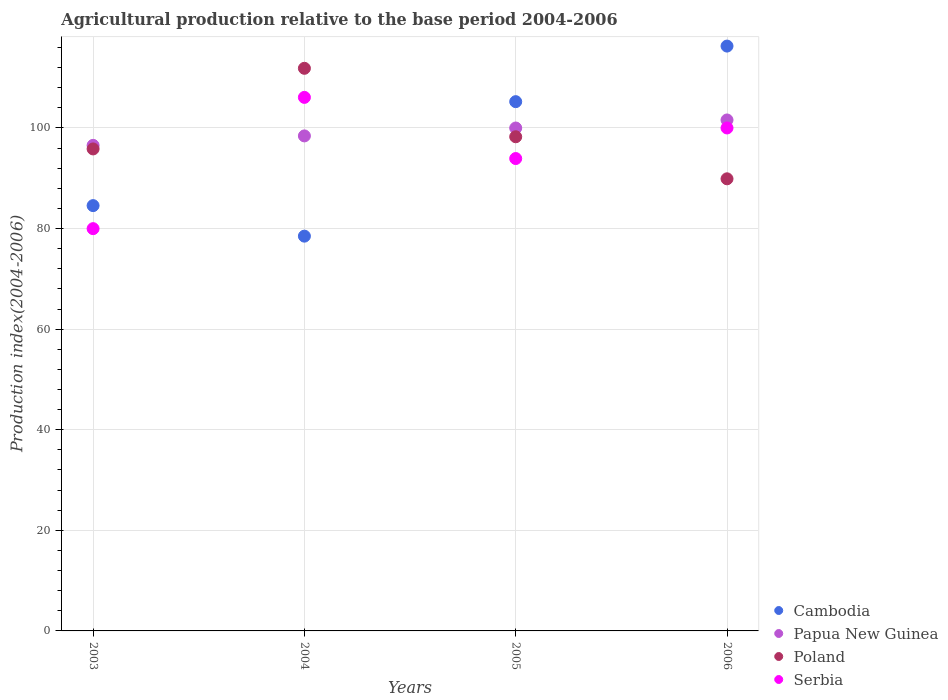Is the number of dotlines equal to the number of legend labels?
Give a very brief answer. Yes. What is the agricultural production index in Serbia in 2005?
Offer a terse response. 93.92. Across all years, what is the maximum agricultural production index in Poland?
Offer a terse response. 111.86. Across all years, what is the minimum agricultural production index in Poland?
Provide a short and direct response. 89.89. In which year was the agricultural production index in Serbia maximum?
Offer a very short reply. 2004. In which year was the agricultural production index in Papua New Guinea minimum?
Offer a terse response. 2003. What is the total agricultural production index in Cambodia in the graph?
Provide a succinct answer. 384.56. What is the difference between the agricultural production index in Cambodia in 2003 and that in 2004?
Provide a succinct answer. 6.07. What is the difference between the agricultural production index in Cambodia in 2006 and the agricultural production index in Poland in 2003?
Your answer should be compact. 20.45. What is the average agricultural production index in Cambodia per year?
Make the answer very short. 96.14. In the year 2005, what is the difference between the agricultural production index in Serbia and agricultural production index in Papua New Guinea?
Provide a short and direct response. -6.07. In how many years, is the agricultural production index in Cambodia greater than 24?
Keep it short and to the point. 4. What is the ratio of the agricultural production index in Poland in 2004 to that in 2006?
Ensure brevity in your answer.  1.24. Is the agricultural production index in Poland in 2003 less than that in 2005?
Your answer should be very brief. Yes. Is the difference between the agricultural production index in Serbia in 2005 and 2006 greater than the difference between the agricultural production index in Papua New Guinea in 2005 and 2006?
Ensure brevity in your answer.  No. What is the difference between the highest and the second highest agricultural production index in Serbia?
Make the answer very short. 6.08. What is the difference between the highest and the lowest agricultural production index in Poland?
Your answer should be very brief. 21.97. Is the agricultural production index in Serbia strictly greater than the agricultural production index in Poland over the years?
Offer a very short reply. No. Are the values on the major ticks of Y-axis written in scientific E-notation?
Your answer should be very brief. No. Does the graph contain grids?
Offer a terse response. Yes. How many legend labels are there?
Give a very brief answer. 4. How are the legend labels stacked?
Provide a short and direct response. Vertical. What is the title of the graph?
Your answer should be very brief. Agricultural production relative to the base period 2004-2006. What is the label or title of the X-axis?
Keep it short and to the point. Years. What is the label or title of the Y-axis?
Your answer should be compact. Production index(2004-2006). What is the Production index(2004-2006) of Cambodia in 2003?
Ensure brevity in your answer.  84.56. What is the Production index(2004-2006) of Papua New Guinea in 2003?
Provide a short and direct response. 96.54. What is the Production index(2004-2006) of Poland in 2003?
Offer a terse response. 95.83. What is the Production index(2004-2006) in Serbia in 2003?
Provide a succinct answer. 79.98. What is the Production index(2004-2006) in Cambodia in 2004?
Offer a very short reply. 78.49. What is the Production index(2004-2006) in Papua New Guinea in 2004?
Ensure brevity in your answer.  98.42. What is the Production index(2004-2006) of Poland in 2004?
Your answer should be very brief. 111.86. What is the Production index(2004-2006) of Serbia in 2004?
Give a very brief answer. 106.08. What is the Production index(2004-2006) of Cambodia in 2005?
Keep it short and to the point. 105.23. What is the Production index(2004-2006) of Papua New Guinea in 2005?
Keep it short and to the point. 99.99. What is the Production index(2004-2006) in Poland in 2005?
Offer a very short reply. 98.25. What is the Production index(2004-2006) of Serbia in 2005?
Provide a succinct answer. 93.92. What is the Production index(2004-2006) of Cambodia in 2006?
Give a very brief answer. 116.28. What is the Production index(2004-2006) in Papua New Guinea in 2006?
Make the answer very short. 101.59. What is the Production index(2004-2006) in Poland in 2006?
Offer a very short reply. 89.89. What is the Production index(2004-2006) of Serbia in 2006?
Provide a short and direct response. 100. Across all years, what is the maximum Production index(2004-2006) of Cambodia?
Your answer should be compact. 116.28. Across all years, what is the maximum Production index(2004-2006) of Papua New Guinea?
Offer a terse response. 101.59. Across all years, what is the maximum Production index(2004-2006) in Poland?
Ensure brevity in your answer.  111.86. Across all years, what is the maximum Production index(2004-2006) in Serbia?
Make the answer very short. 106.08. Across all years, what is the minimum Production index(2004-2006) of Cambodia?
Your answer should be compact. 78.49. Across all years, what is the minimum Production index(2004-2006) of Papua New Guinea?
Your response must be concise. 96.54. Across all years, what is the minimum Production index(2004-2006) of Poland?
Give a very brief answer. 89.89. Across all years, what is the minimum Production index(2004-2006) in Serbia?
Give a very brief answer. 79.98. What is the total Production index(2004-2006) in Cambodia in the graph?
Offer a terse response. 384.56. What is the total Production index(2004-2006) in Papua New Guinea in the graph?
Provide a succinct answer. 396.54. What is the total Production index(2004-2006) of Poland in the graph?
Keep it short and to the point. 395.83. What is the total Production index(2004-2006) in Serbia in the graph?
Your answer should be very brief. 379.98. What is the difference between the Production index(2004-2006) in Cambodia in 2003 and that in 2004?
Give a very brief answer. 6.07. What is the difference between the Production index(2004-2006) in Papua New Guinea in 2003 and that in 2004?
Your answer should be very brief. -1.88. What is the difference between the Production index(2004-2006) in Poland in 2003 and that in 2004?
Offer a terse response. -16.03. What is the difference between the Production index(2004-2006) of Serbia in 2003 and that in 2004?
Offer a very short reply. -26.1. What is the difference between the Production index(2004-2006) in Cambodia in 2003 and that in 2005?
Give a very brief answer. -20.67. What is the difference between the Production index(2004-2006) in Papua New Guinea in 2003 and that in 2005?
Give a very brief answer. -3.45. What is the difference between the Production index(2004-2006) of Poland in 2003 and that in 2005?
Provide a succinct answer. -2.42. What is the difference between the Production index(2004-2006) of Serbia in 2003 and that in 2005?
Make the answer very short. -13.94. What is the difference between the Production index(2004-2006) of Cambodia in 2003 and that in 2006?
Give a very brief answer. -31.72. What is the difference between the Production index(2004-2006) of Papua New Guinea in 2003 and that in 2006?
Ensure brevity in your answer.  -5.05. What is the difference between the Production index(2004-2006) in Poland in 2003 and that in 2006?
Your response must be concise. 5.94. What is the difference between the Production index(2004-2006) of Serbia in 2003 and that in 2006?
Give a very brief answer. -20.02. What is the difference between the Production index(2004-2006) in Cambodia in 2004 and that in 2005?
Offer a very short reply. -26.74. What is the difference between the Production index(2004-2006) in Papua New Guinea in 2004 and that in 2005?
Your answer should be compact. -1.57. What is the difference between the Production index(2004-2006) in Poland in 2004 and that in 2005?
Offer a terse response. 13.61. What is the difference between the Production index(2004-2006) in Serbia in 2004 and that in 2005?
Make the answer very short. 12.16. What is the difference between the Production index(2004-2006) in Cambodia in 2004 and that in 2006?
Provide a short and direct response. -37.79. What is the difference between the Production index(2004-2006) of Papua New Guinea in 2004 and that in 2006?
Offer a very short reply. -3.17. What is the difference between the Production index(2004-2006) of Poland in 2004 and that in 2006?
Provide a succinct answer. 21.97. What is the difference between the Production index(2004-2006) in Serbia in 2004 and that in 2006?
Your answer should be compact. 6.08. What is the difference between the Production index(2004-2006) of Cambodia in 2005 and that in 2006?
Give a very brief answer. -11.05. What is the difference between the Production index(2004-2006) in Poland in 2005 and that in 2006?
Your response must be concise. 8.36. What is the difference between the Production index(2004-2006) in Serbia in 2005 and that in 2006?
Make the answer very short. -6.08. What is the difference between the Production index(2004-2006) of Cambodia in 2003 and the Production index(2004-2006) of Papua New Guinea in 2004?
Provide a succinct answer. -13.86. What is the difference between the Production index(2004-2006) of Cambodia in 2003 and the Production index(2004-2006) of Poland in 2004?
Your answer should be very brief. -27.3. What is the difference between the Production index(2004-2006) in Cambodia in 2003 and the Production index(2004-2006) in Serbia in 2004?
Make the answer very short. -21.52. What is the difference between the Production index(2004-2006) in Papua New Guinea in 2003 and the Production index(2004-2006) in Poland in 2004?
Give a very brief answer. -15.32. What is the difference between the Production index(2004-2006) of Papua New Guinea in 2003 and the Production index(2004-2006) of Serbia in 2004?
Provide a succinct answer. -9.54. What is the difference between the Production index(2004-2006) in Poland in 2003 and the Production index(2004-2006) in Serbia in 2004?
Provide a short and direct response. -10.25. What is the difference between the Production index(2004-2006) of Cambodia in 2003 and the Production index(2004-2006) of Papua New Guinea in 2005?
Give a very brief answer. -15.43. What is the difference between the Production index(2004-2006) of Cambodia in 2003 and the Production index(2004-2006) of Poland in 2005?
Provide a succinct answer. -13.69. What is the difference between the Production index(2004-2006) in Cambodia in 2003 and the Production index(2004-2006) in Serbia in 2005?
Offer a terse response. -9.36. What is the difference between the Production index(2004-2006) in Papua New Guinea in 2003 and the Production index(2004-2006) in Poland in 2005?
Your answer should be compact. -1.71. What is the difference between the Production index(2004-2006) of Papua New Guinea in 2003 and the Production index(2004-2006) of Serbia in 2005?
Offer a very short reply. 2.62. What is the difference between the Production index(2004-2006) in Poland in 2003 and the Production index(2004-2006) in Serbia in 2005?
Give a very brief answer. 1.91. What is the difference between the Production index(2004-2006) of Cambodia in 2003 and the Production index(2004-2006) of Papua New Guinea in 2006?
Ensure brevity in your answer.  -17.03. What is the difference between the Production index(2004-2006) in Cambodia in 2003 and the Production index(2004-2006) in Poland in 2006?
Provide a short and direct response. -5.33. What is the difference between the Production index(2004-2006) in Cambodia in 2003 and the Production index(2004-2006) in Serbia in 2006?
Offer a very short reply. -15.44. What is the difference between the Production index(2004-2006) of Papua New Guinea in 2003 and the Production index(2004-2006) of Poland in 2006?
Give a very brief answer. 6.65. What is the difference between the Production index(2004-2006) of Papua New Guinea in 2003 and the Production index(2004-2006) of Serbia in 2006?
Ensure brevity in your answer.  -3.46. What is the difference between the Production index(2004-2006) of Poland in 2003 and the Production index(2004-2006) of Serbia in 2006?
Keep it short and to the point. -4.17. What is the difference between the Production index(2004-2006) in Cambodia in 2004 and the Production index(2004-2006) in Papua New Guinea in 2005?
Make the answer very short. -21.5. What is the difference between the Production index(2004-2006) of Cambodia in 2004 and the Production index(2004-2006) of Poland in 2005?
Provide a short and direct response. -19.76. What is the difference between the Production index(2004-2006) of Cambodia in 2004 and the Production index(2004-2006) of Serbia in 2005?
Provide a short and direct response. -15.43. What is the difference between the Production index(2004-2006) of Papua New Guinea in 2004 and the Production index(2004-2006) of Poland in 2005?
Keep it short and to the point. 0.17. What is the difference between the Production index(2004-2006) in Poland in 2004 and the Production index(2004-2006) in Serbia in 2005?
Keep it short and to the point. 17.94. What is the difference between the Production index(2004-2006) in Cambodia in 2004 and the Production index(2004-2006) in Papua New Guinea in 2006?
Your answer should be compact. -23.1. What is the difference between the Production index(2004-2006) of Cambodia in 2004 and the Production index(2004-2006) of Poland in 2006?
Your response must be concise. -11.4. What is the difference between the Production index(2004-2006) of Cambodia in 2004 and the Production index(2004-2006) of Serbia in 2006?
Your answer should be compact. -21.51. What is the difference between the Production index(2004-2006) of Papua New Guinea in 2004 and the Production index(2004-2006) of Poland in 2006?
Provide a short and direct response. 8.53. What is the difference between the Production index(2004-2006) of Papua New Guinea in 2004 and the Production index(2004-2006) of Serbia in 2006?
Provide a short and direct response. -1.58. What is the difference between the Production index(2004-2006) of Poland in 2004 and the Production index(2004-2006) of Serbia in 2006?
Your response must be concise. 11.86. What is the difference between the Production index(2004-2006) in Cambodia in 2005 and the Production index(2004-2006) in Papua New Guinea in 2006?
Give a very brief answer. 3.64. What is the difference between the Production index(2004-2006) of Cambodia in 2005 and the Production index(2004-2006) of Poland in 2006?
Give a very brief answer. 15.34. What is the difference between the Production index(2004-2006) in Cambodia in 2005 and the Production index(2004-2006) in Serbia in 2006?
Your answer should be very brief. 5.23. What is the difference between the Production index(2004-2006) of Papua New Guinea in 2005 and the Production index(2004-2006) of Serbia in 2006?
Your answer should be compact. -0.01. What is the difference between the Production index(2004-2006) in Poland in 2005 and the Production index(2004-2006) in Serbia in 2006?
Your answer should be compact. -1.75. What is the average Production index(2004-2006) in Cambodia per year?
Offer a very short reply. 96.14. What is the average Production index(2004-2006) of Papua New Guinea per year?
Keep it short and to the point. 99.14. What is the average Production index(2004-2006) of Poland per year?
Ensure brevity in your answer.  98.96. What is the average Production index(2004-2006) of Serbia per year?
Your answer should be very brief. 95. In the year 2003, what is the difference between the Production index(2004-2006) of Cambodia and Production index(2004-2006) of Papua New Guinea?
Keep it short and to the point. -11.98. In the year 2003, what is the difference between the Production index(2004-2006) in Cambodia and Production index(2004-2006) in Poland?
Provide a succinct answer. -11.27. In the year 2003, what is the difference between the Production index(2004-2006) of Cambodia and Production index(2004-2006) of Serbia?
Provide a succinct answer. 4.58. In the year 2003, what is the difference between the Production index(2004-2006) in Papua New Guinea and Production index(2004-2006) in Poland?
Provide a succinct answer. 0.71. In the year 2003, what is the difference between the Production index(2004-2006) in Papua New Guinea and Production index(2004-2006) in Serbia?
Offer a very short reply. 16.56. In the year 2003, what is the difference between the Production index(2004-2006) of Poland and Production index(2004-2006) of Serbia?
Your answer should be very brief. 15.85. In the year 2004, what is the difference between the Production index(2004-2006) in Cambodia and Production index(2004-2006) in Papua New Guinea?
Keep it short and to the point. -19.93. In the year 2004, what is the difference between the Production index(2004-2006) in Cambodia and Production index(2004-2006) in Poland?
Your answer should be very brief. -33.37. In the year 2004, what is the difference between the Production index(2004-2006) in Cambodia and Production index(2004-2006) in Serbia?
Give a very brief answer. -27.59. In the year 2004, what is the difference between the Production index(2004-2006) in Papua New Guinea and Production index(2004-2006) in Poland?
Keep it short and to the point. -13.44. In the year 2004, what is the difference between the Production index(2004-2006) in Papua New Guinea and Production index(2004-2006) in Serbia?
Offer a very short reply. -7.66. In the year 2004, what is the difference between the Production index(2004-2006) in Poland and Production index(2004-2006) in Serbia?
Your answer should be compact. 5.78. In the year 2005, what is the difference between the Production index(2004-2006) in Cambodia and Production index(2004-2006) in Papua New Guinea?
Your answer should be very brief. 5.24. In the year 2005, what is the difference between the Production index(2004-2006) of Cambodia and Production index(2004-2006) of Poland?
Your answer should be compact. 6.98. In the year 2005, what is the difference between the Production index(2004-2006) in Cambodia and Production index(2004-2006) in Serbia?
Offer a terse response. 11.31. In the year 2005, what is the difference between the Production index(2004-2006) of Papua New Guinea and Production index(2004-2006) of Poland?
Keep it short and to the point. 1.74. In the year 2005, what is the difference between the Production index(2004-2006) of Papua New Guinea and Production index(2004-2006) of Serbia?
Make the answer very short. 6.07. In the year 2005, what is the difference between the Production index(2004-2006) of Poland and Production index(2004-2006) of Serbia?
Ensure brevity in your answer.  4.33. In the year 2006, what is the difference between the Production index(2004-2006) of Cambodia and Production index(2004-2006) of Papua New Guinea?
Provide a succinct answer. 14.69. In the year 2006, what is the difference between the Production index(2004-2006) in Cambodia and Production index(2004-2006) in Poland?
Provide a short and direct response. 26.39. In the year 2006, what is the difference between the Production index(2004-2006) of Cambodia and Production index(2004-2006) of Serbia?
Make the answer very short. 16.28. In the year 2006, what is the difference between the Production index(2004-2006) in Papua New Guinea and Production index(2004-2006) in Serbia?
Give a very brief answer. 1.59. In the year 2006, what is the difference between the Production index(2004-2006) of Poland and Production index(2004-2006) of Serbia?
Give a very brief answer. -10.11. What is the ratio of the Production index(2004-2006) in Cambodia in 2003 to that in 2004?
Your response must be concise. 1.08. What is the ratio of the Production index(2004-2006) in Papua New Guinea in 2003 to that in 2004?
Offer a terse response. 0.98. What is the ratio of the Production index(2004-2006) of Poland in 2003 to that in 2004?
Make the answer very short. 0.86. What is the ratio of the Production index(2004-2006) in Serbia in 2003 to that in 2004?
Give a very brief answer. 0.75. What is the ratio of the Production index(2004-2006) in Cambodia in 2003 to that in 2005?
Provide a short and direct response. 0.8. What is the ratio of the Production index(2004-2006) in Papua New Guinea in 2003 to that in 2005?
Your response must be concise. 0.97. What is the ratio of the Production index(2004-2006) of Poland in 2003 to that in 2005?
Ensure brevity in your answer.  0.98. What is the ratio of the Production index(2004-2006) of Serbia in 2003 to that in 2005?
Your answer should be very brief. 0.85. What is the ratio of the Production index(2004-2006) in Cambodia in 2003 to that in 2006?
Offer a terse response. 0.73. What is the ratio of the Production index(2004-2006) of Papua New Guinea in 2003 to that in 2006?
Provide a short and direct response. 0.95. What is the ratio of the Production index(2004-2006) of Poland in 2003 to that in 2006?
Give a very brief answer. 1.07. What is the ratio of the Production index(2004-2006) in Serbia in 2003 to that in 2006?
Make the answer very short. 0.8. What is the ratio of the Production index(2004-2006) in Cambodia in 2004 to that in 2005?
Your response must be concise. 0.75. What is the ratio of the Production index(2004-2006) in Papua New Guinea in 2004 to that in 2005?
Keep it short and to the point. 0.98. What is the ratio of the Production index(2004-2006) of Poland in 2004 to that in 2005?
Offer a terse response. 1.14. What is the ratio of the Production index(2004-2006) of Serbia in 2004 to that in 2005?
Provide a short and direct response. 1.13. What is the ratio of the Production index(2004-2006) of Cambodia in 2004 to that in 2006?
Ensure brevity in your answer.  0.68. What is the ratio of the Production index(2004-2006) in Papua New Guinea in 2004 to that in 2006?
Make the answer very short. 0.97. What is the ratio of the Production index(2004-2006) of Poland in 2004 to that in 2006?
Provide a succinct answer. 1.24. What is the ratio of the Production index(2004-2006) in Serbia in 2004 to that in 2006?
Your response must be concise. 1.06. What is the ratio of the Production index(2004-2006) in Cambodia in 2005 to that in 2006?
Keep it short and to the point. 0.91. What is the ratio of the Production index(2004-2006) in Papua New Guinea in 2005 to that in 2006?
Give a very brief answer. 0.98. What is the ratio of the Production index(2004-2006) in Poland in 2005 to that in 2006?
Make the answer very short. 1.09. What is the ratio of the Production index(2004-2006) in Serbia in 2005 to that in 2006?
Make the answer very short. 0.94. What is the difference between the highest and the second highest Production index(2004-2006) in Cambodia?
Offer a very short reply. 11.05. What is the difference between the highest and the second highest Production index(2004-2006) of Papua New Guinea?
Your answer should be very brief. 1.6. What is the difference between the highest and the second highest Production index(2004-2006) of Poland?
Keep it short and to the point. 13.61. What is the difference between the highest and the second highest Production index(2004-2006) in Serbia?
Offer a very short reply. 6.08. What is the difference between the highest and the lowest Production index(2004-2006) in Cambodia?
Your answer should be compact. 37.79. What is the difference between the highest and the lowest Production index(2004-2006) of Papua New Guinea?
Provide a short and direct response. 5.05. What is the difference between the highest and the lowest Production index(2004-2006) in Poland?
Provide a succinct answer. 21.97. What is the difference between the highest and the lowest Production index(2004-2006) in Serbia?
Ensure brevity in your answer.  26.1. 